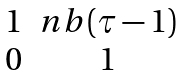Convert formula to latex. <formula><loc_0><loc_0><loc_500><loc_500>\begin{matrix} 1 & n b ( \tau - 1 ) \\ 0 & 1 \end{matrix}</formula> 